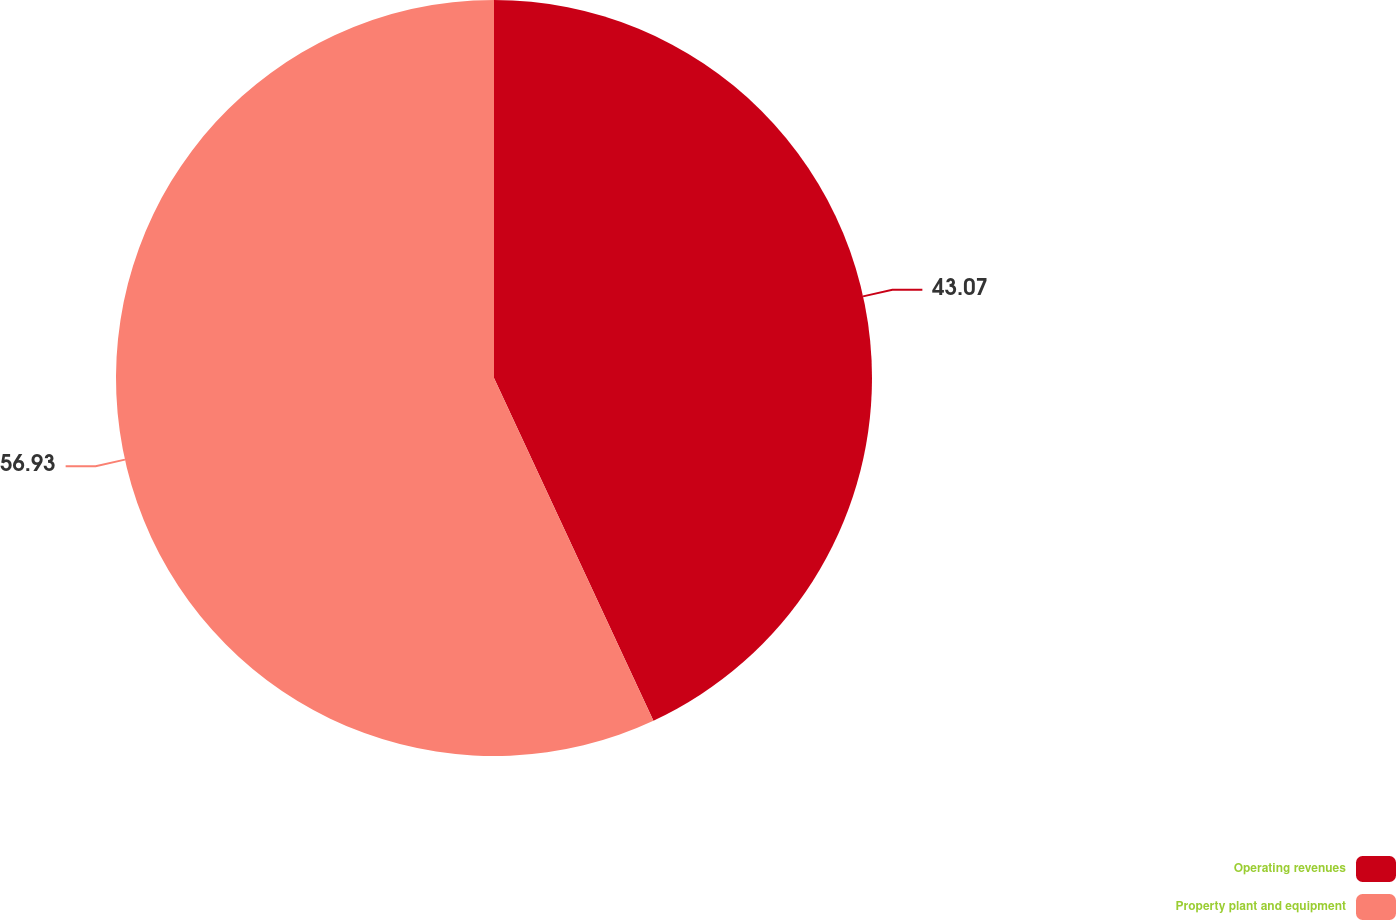<chart> <loc_0><loc_0><loc_500><loc_500><pie_chart><fcel>Operating revenues<fcel>Property plant and equipment<nl><fcel>43.07%<fcel>56.93%<nl></chart> 